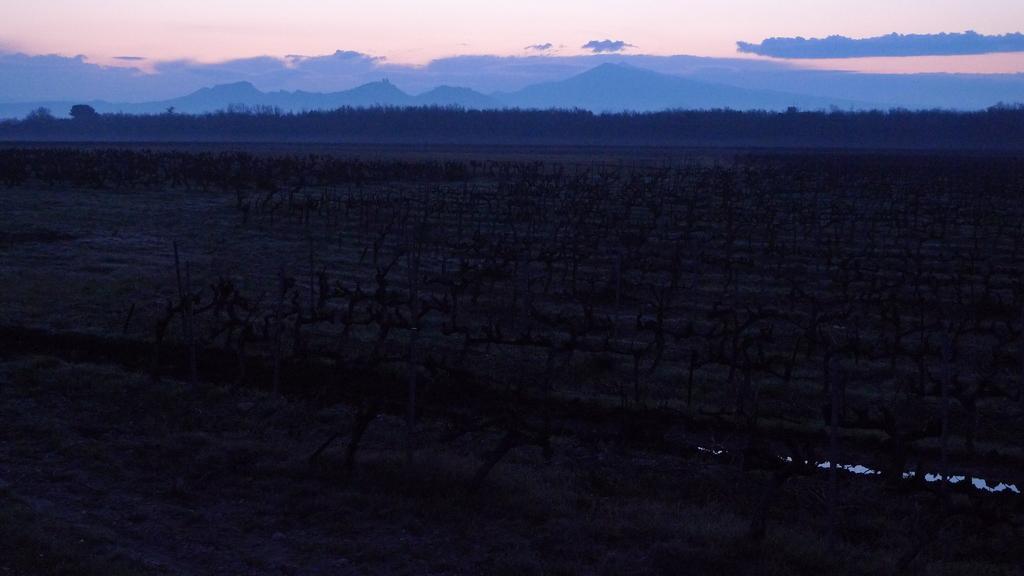Please provide a concise description of this image. In this picture there is field at the bottom side of the image and there is sky at the top side of the image. 